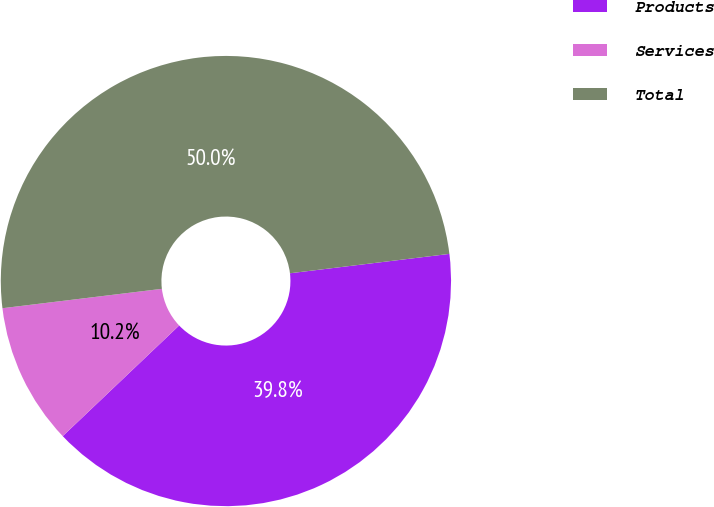Convert chart to OTSL. <chart><loc_0><loc_0><loc_500><loc_500><pie_chart><fcel>Products<fcel>Services<fcel>Total<nl><fcel>39.83%<fcel>10.17%<fcel>50.0%<nl></chart> 